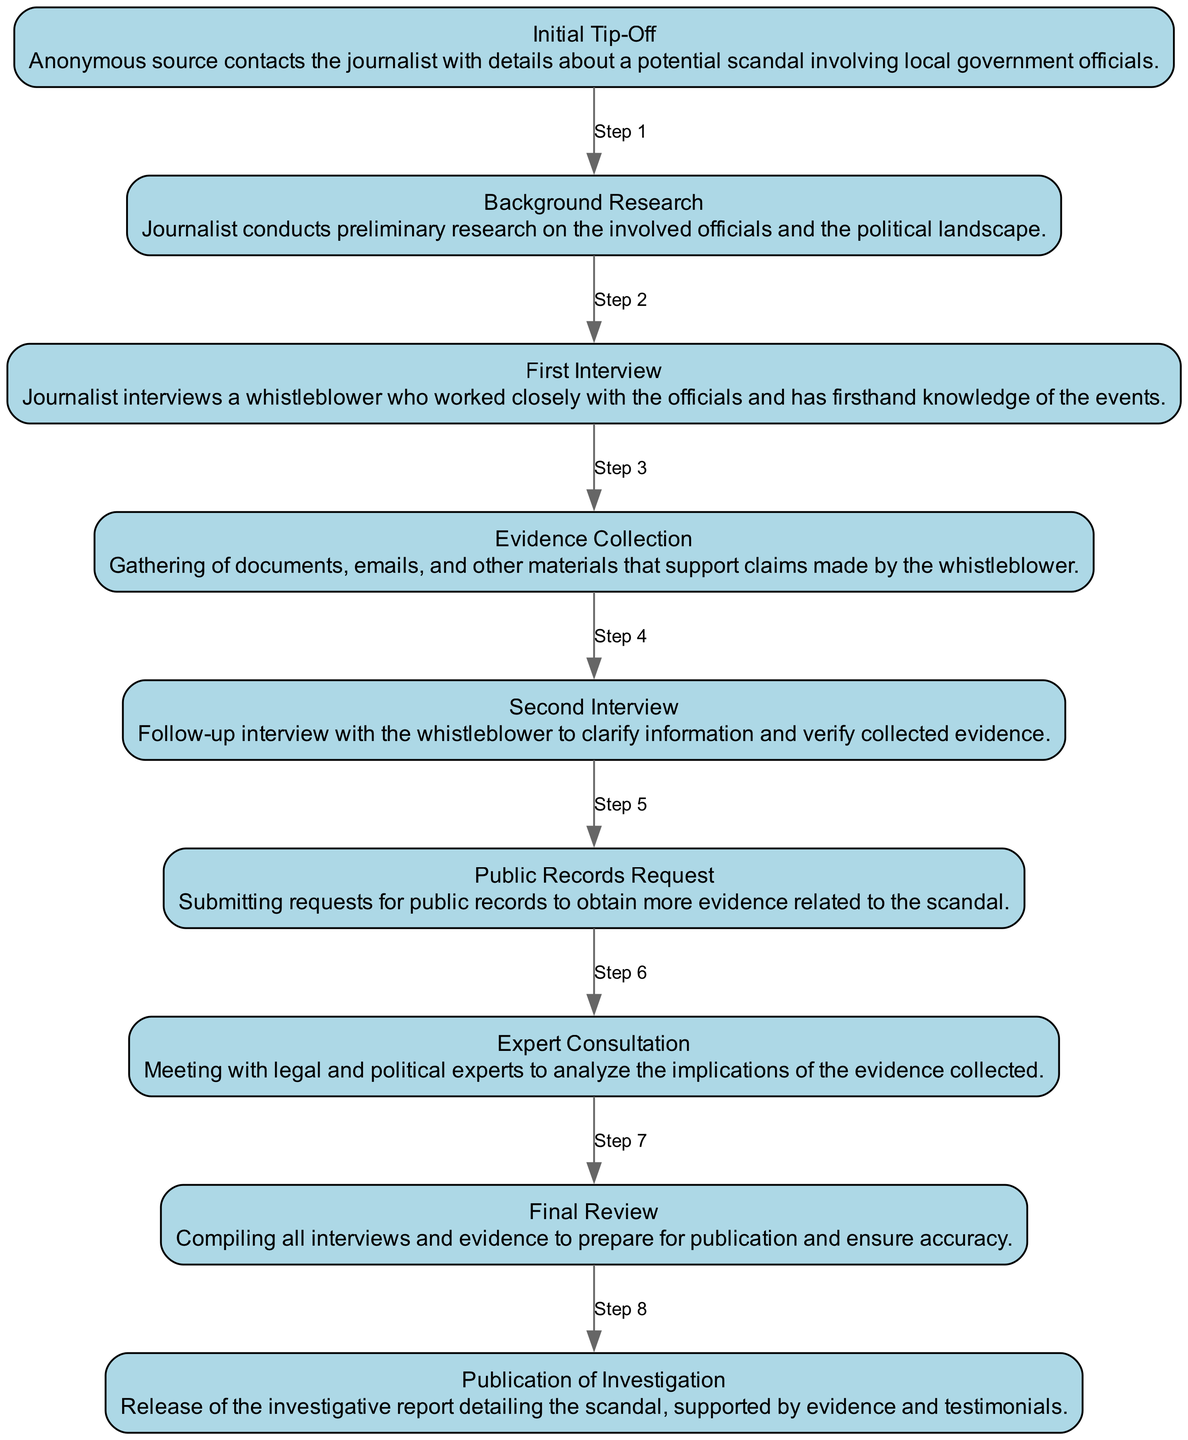What is the first event in the diagram? The first event listed in the diagram is "Initial Tip-Off", which signifies the start of the investigation based on an anonymous source's information.
Answer: Initial Tip-Off How many total events are present in the diagram? By counting each of the listed elements in the diagram, we can see that there are a total of nine distinct events outlined.
Answer: 9 What is the second event in the timeline? The second event that follows the first event in the diagram is "Background Research," indicating the journalist's preliminary work.
Answer: Background Research Which event immediately follows the "First Interview"? The event that immediately follows the "First Interview" is "Evidence Collection," which highlights the next step in the journalist's investigation process.
Answer: Evidence Collection What type of experts do the journalists consult after evidence collection? After collecting evidence, the journalist meets with legal and political experts to analyze the implications, providing necessary context for the investigation.
Answer: Legal and political What is the relationship between "Second Interview" and "Evidence Collection"? The "Second Interview" occurs after the "Evidence Collection," indicating that the journalist seeks to verify the information gathered through further questioning of the whistleblower.
Answer: Follow-up verification How many requests for public records are made in the process? The diagram indicates that only a single "Public Records Request" is submitted as part of the investigation process to gather more evidence.
Answer: 1 During what stage does the publication of the investigation occur? The stage of the diagram that leads to the "Publication of Investigation" is after the "Final Review," emphasizing that all information is vetted before release.
Answer: Final Review What is the last event in the sequence? The last event in the sequence represents the culmination of the investigation process, which is the "Publication of Investigation."
Answer: Publication of Investigation 